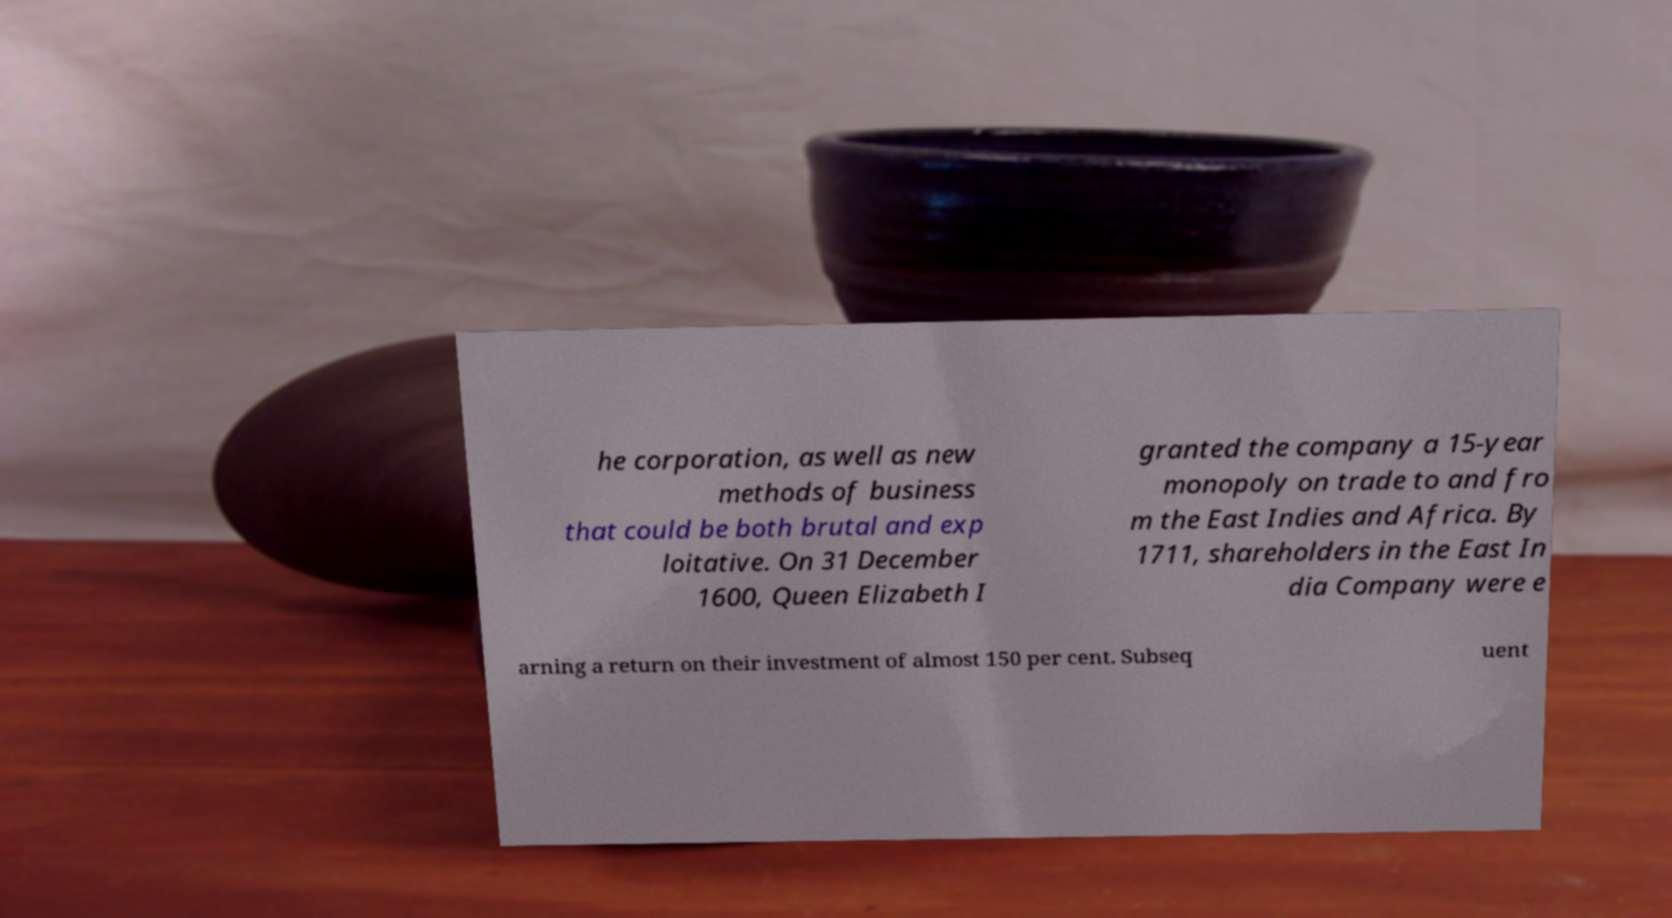Can you accurately transcribe the text from the provided image for me? he corporation, as well as new methods of business that could be both brutal and exp loitative. On 31 December 1600, Queen Elizabeth I granted the company a 15-year monopoly on trade to and fro m the East Indies and Africa. By 1711, shareholders in the East In dia Company were e arning a return on their investment of almost 150 per cent. Subseq uent 